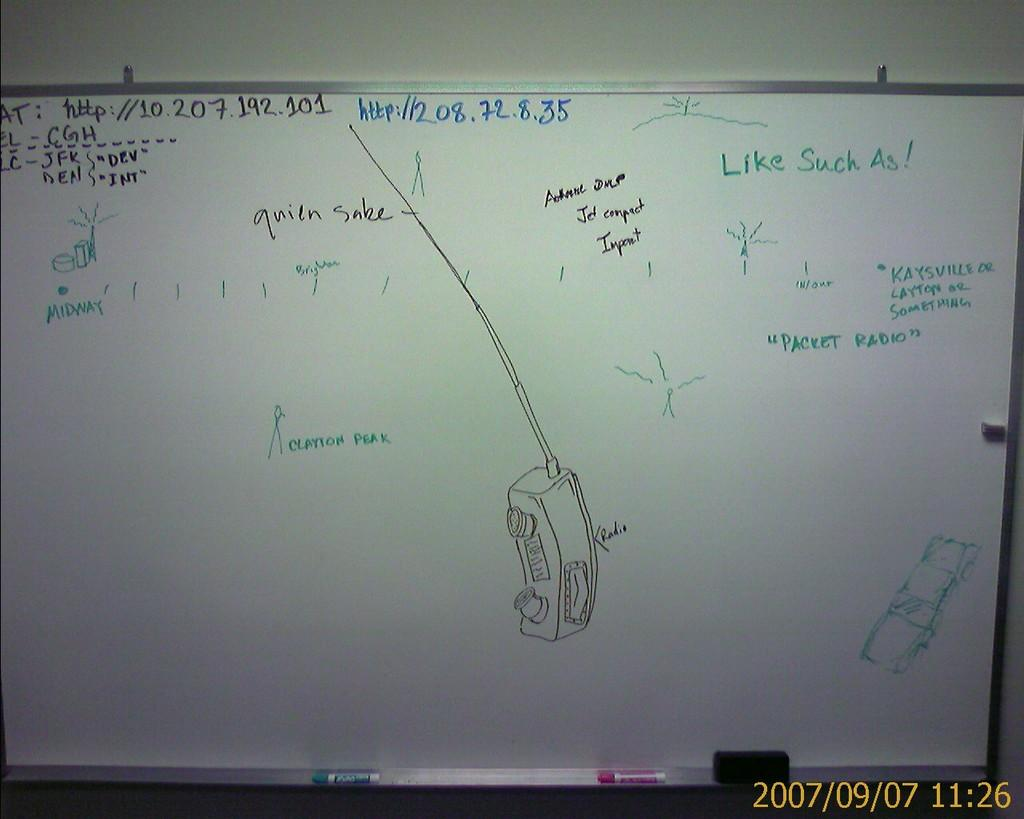<image>
Render a clear and concise summary of the photo. the number 35 is on the white board outside 